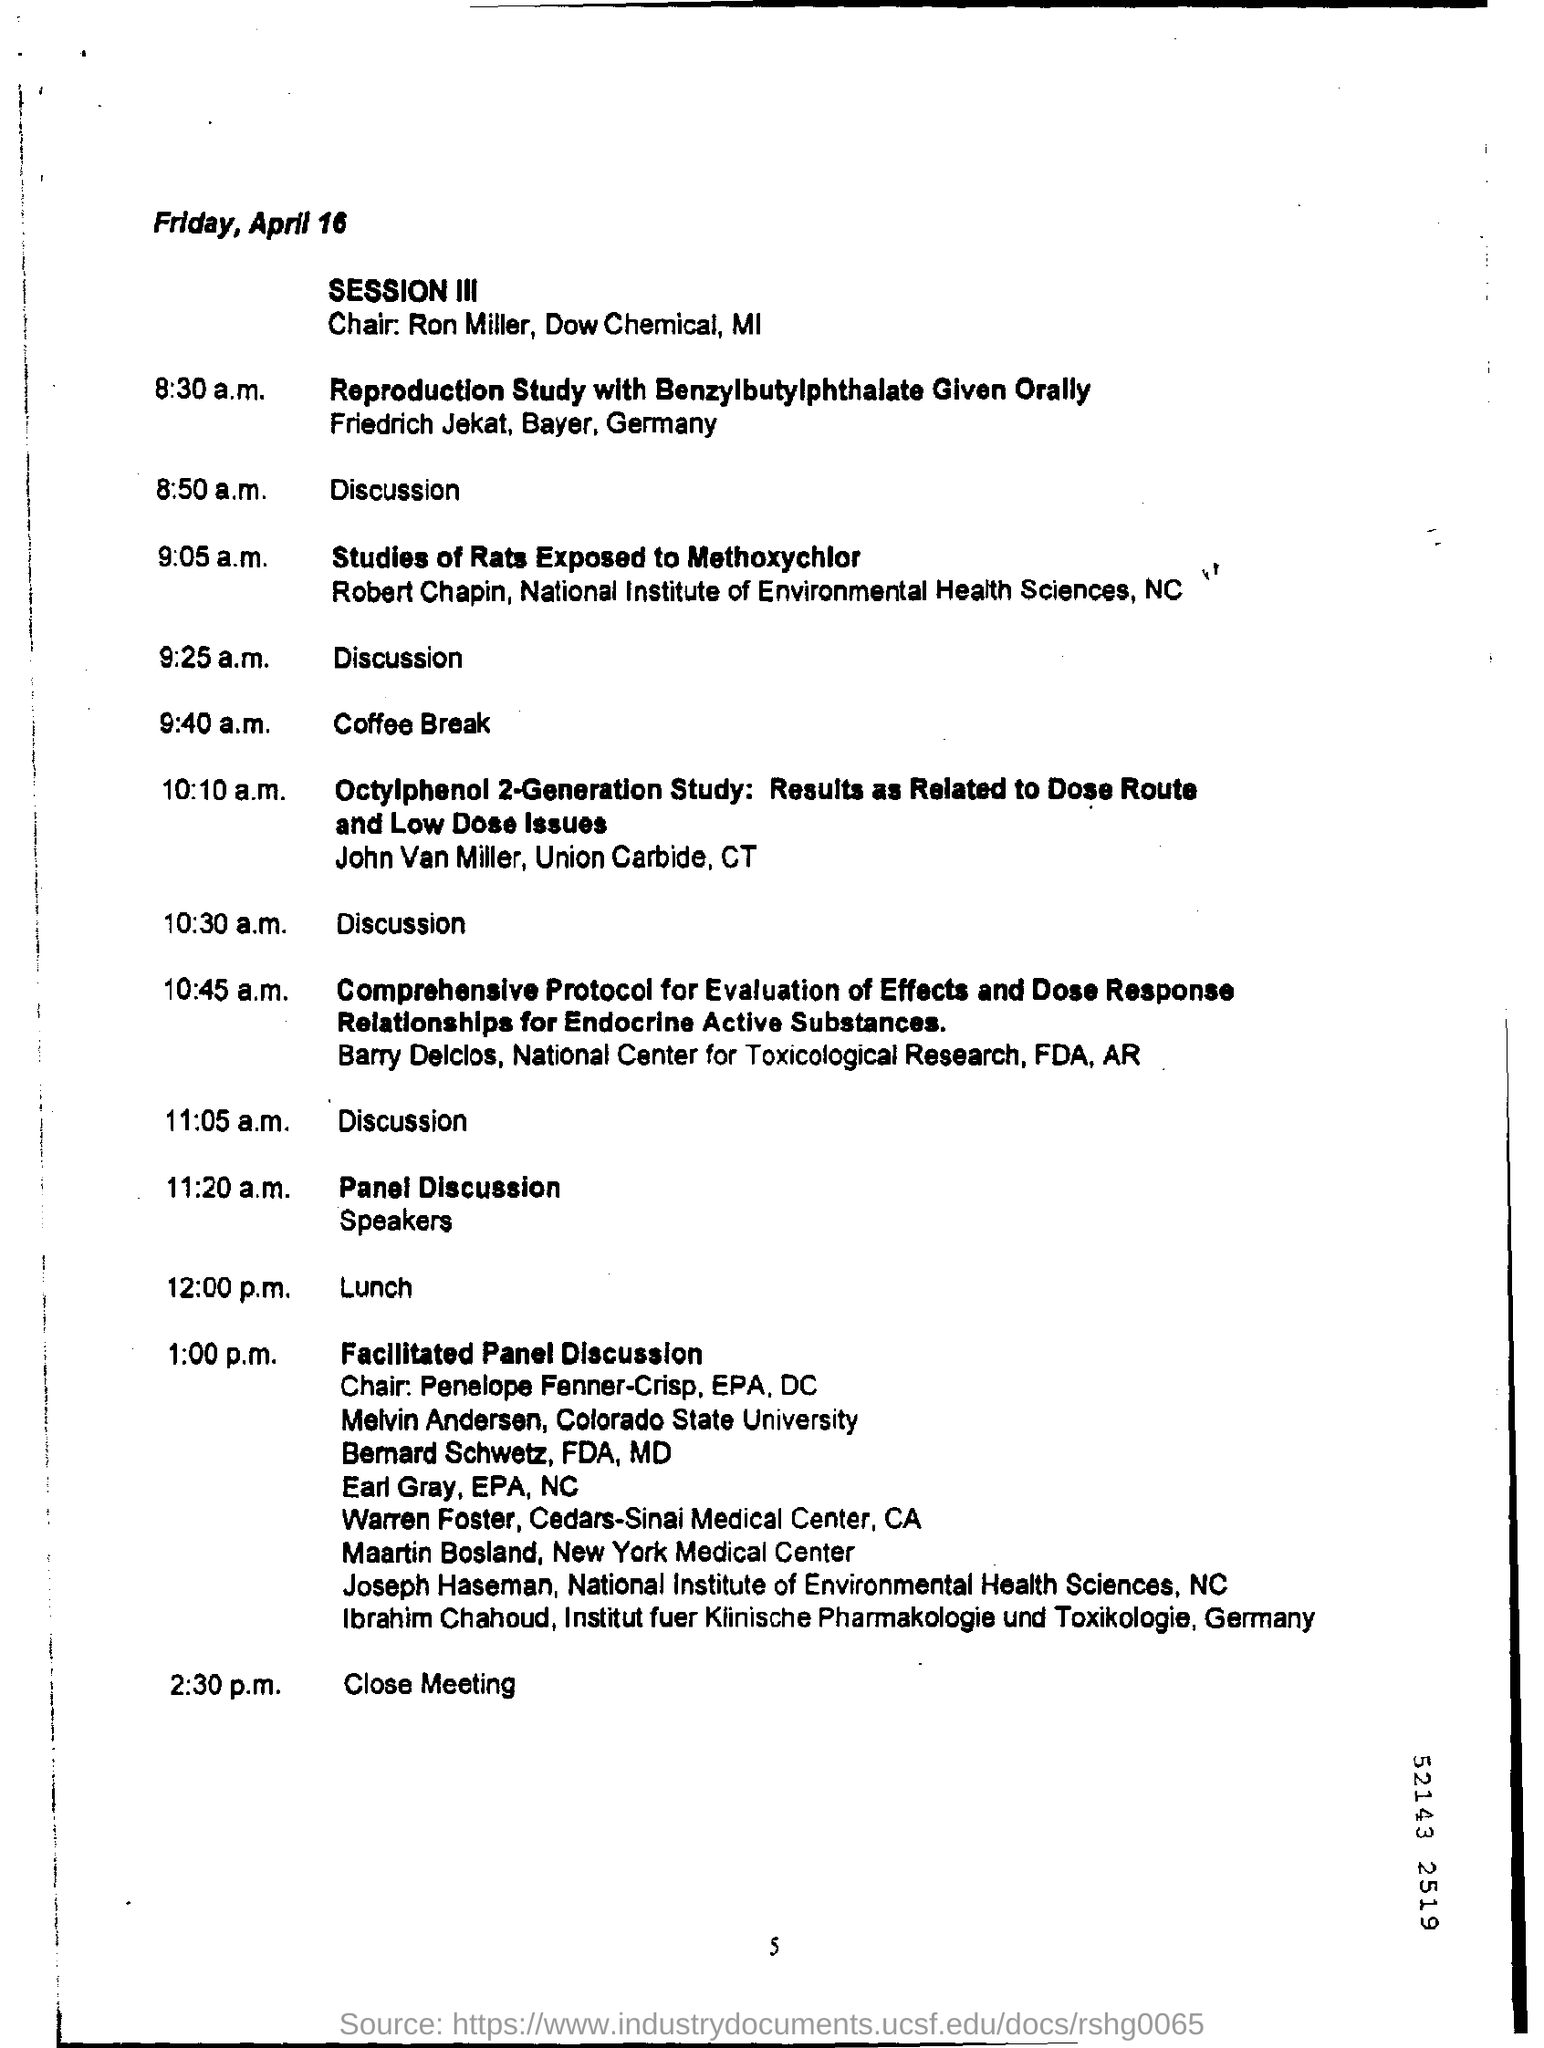What day of the week is april 16?
Give a very brief answer. Friday. What is the number at bottom of the page ?
Provide a succinct answer. 5. When is the coffee break scheduled ?
Give a very brief answer. 9:40 a.m. 